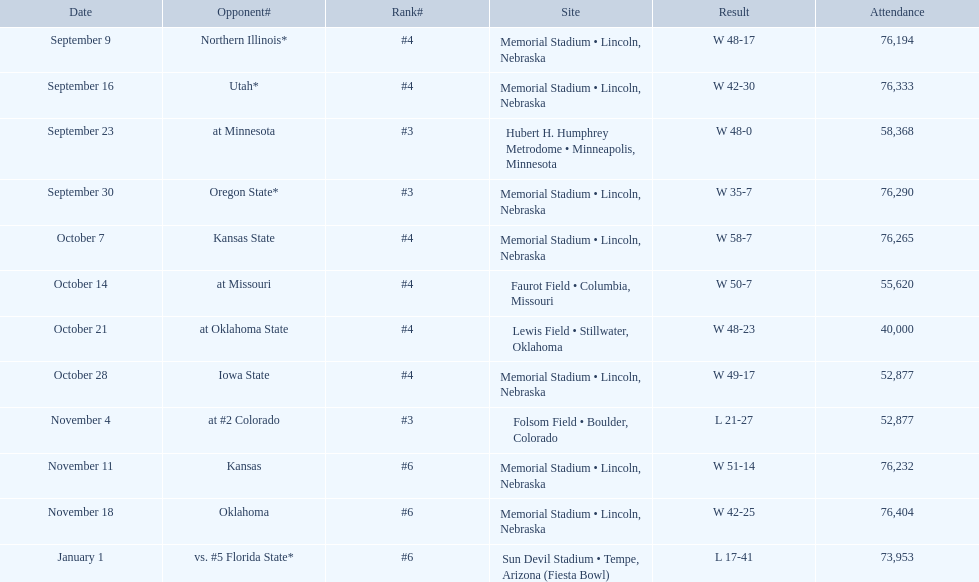In which games did the nebraska cornhuskers score under 40 points against their opponents? Oregon State*, at #2 Colorado, vs. #5 Florida State*. Among these games, which ones had more than 70,000 spectators? Oregon State*, vs. #5 Florida State*. Which of these rival teams were defeated by the cornhuskers? Oregon State*. How many attendees were present at that particular match? 76,290. 